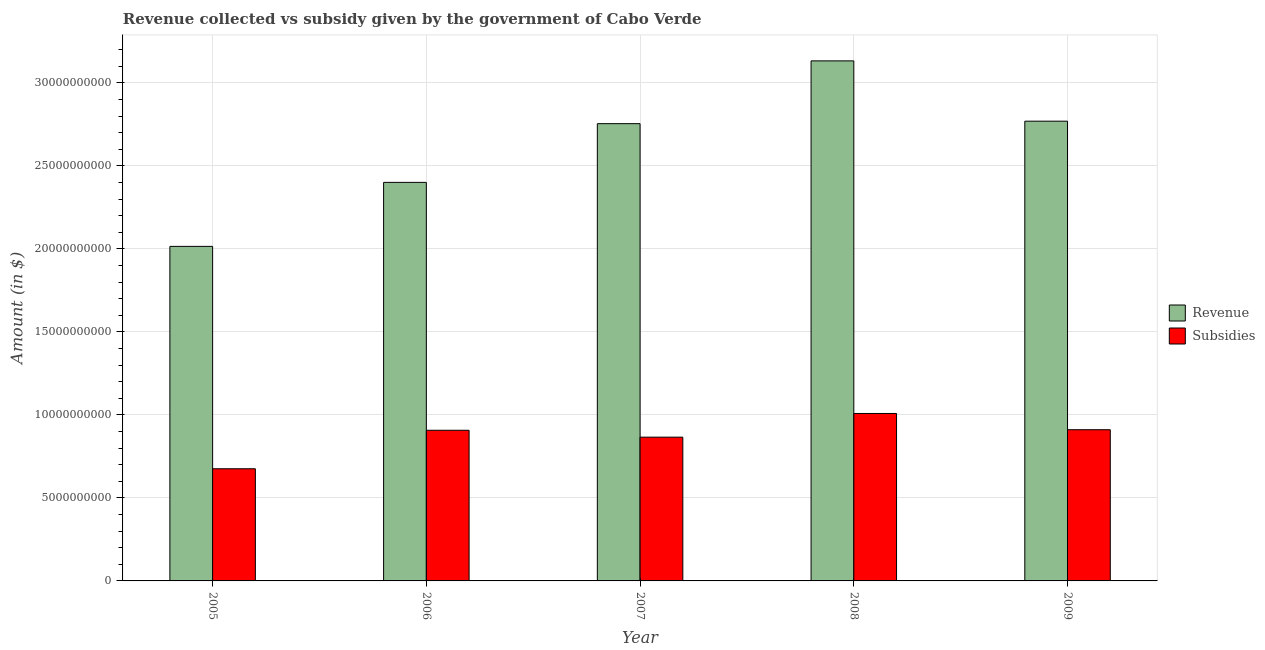How many groups of bars are there?
Keep it short and to the point. 5. Are the number of bars per tick equal to the number of legend labels?
Your answer should be compact. Yes. How many bars are there on the 1st tick from the right?
Your answer should be very brief. 2. In how many cases, is the number of bars for a given year not equal to the number of legend labels?
Give a very brief answer. 0. What is the amount of revenue collected in 2009?
Make the answer very short. 2.77e+1. Across all years, what is the maximum amount of revenue collected?
Provide a succinct answer. 3.13e+1. Across all years, what is the minimum amount of revenue collected?
Give a very brief answer. 2.02e+1. In which year was the amount of revenue collected maximum?
Offer a terse response. 2008. What is the total amount of revenue collected in the graph?
Provide a succinct answer. 1.31e+11. What is the difference between the amount of revenue collected in 2005 and that in 2008?
Offer a very short reply. -1.12e+1. What is the difference between the amount of subsidies given in 2009 and the amount of revenue collected in 2008?
Provide a short and direct response. -9.79e+08. What is the average amount of subsidies given per year?
Your answer should be very brief. 8.74e+09. In the year 2008, what is the difference between the amount of subsidies given and amount of revenue collected?
Keep it short and to the point. 0. In how many years, is the amount of revenue collected greater than 22000000000 $?
Your response must be concise. 4. What is the ratio of the amount of subsidies given in 2005 to that in 2007?
Ensure brevity in your answer.  0.78. What is the difference between the highest and the second highest amount of subsidies given?
Give a very brief answer. 9.79e+08. What is the difference between the highest and the lowest amount of subsidies given?
Your answer should be very brief. 3.33e+09. What does the 2nd bar from the left in 2005 represents?
Offer a very short reply. Subsidies. What does the 1st bar from the right in 2006 represents?
Offer a very short reply. Subsidies. Are all the bars in the graph horizontal?
Give a very brief answer. No. What is the difference between two consecutive major ticks on the Y-axis?
Provide a succinct answer. 5.00e+09. Does the graph contain any zero values?
Provide a short and direct response. No. Does the graph contain grids?
Keep it short and to the point. Yes. How many legend labels are there?
Give a very brief answer. 2. What is the title of the graph?
Offer a very short reply. Revenue collected vs subsidy given by the government of Cabo Verde. Does "Enforce a contract" appear as one of the legend labels in the graph?
Your answer should be very brief. No. What is the label or title of the X-axis?
Your answer should be compact. Year. What is the label or title of the Y-axis?
Provide a short and direct response. Amount (in $). What is the Amount (in $) of Revenue in 2005?
Offer a very short reply. 2.02e+1. What is the Amount (in $) of Subsidies in 2005?
Your answer should be very brief. 6.76e+09. What is the Amount (in $) of Revenue in 2006?
Provide a succinct answer. 2.40e+1. What is the Amount (in $) of Subsidies in 2006?
Make the answer very short. 9.07e+09. What is the Amount (in $) of Revenue in 2007?
Your answer should be compact. 2.75e+1. What is the Amount (in $) of Subsidies in 2007?
Your answer should be very brief. 8.66e+09. What is the Amount (in $) of Revenue in 2008?
Provide a short and direct response. 3.13e+1. What is the Amount (in $) of Subsidies in 2008?
Provide a succinct answer. 1.01e+1. What is the Amount (in $) in Revenue in 2009?
Your answer should be very brief. 2.77e+1. What is the Amount (in $) of Subsidies in 2009?
Provide a short and direct response. 9.11e+09. Across all years, what is the maximum Amount (in $) of Revenue?
Provide a short and direct response. 3.13e+1. Across all years, what is the maximum Amount (in $) of Subsidies?
Offer a very short reply. 1.01e+1. Across all years, what is the minimum Amount (in $) of Revenue?
Offer a very short reply. 2.02e+1. Across all years, what is the minimum Amount (in $) in Subsidies?
Your answer should be very brief. 6.76e+09. What is the total Amount (in $) in Revenue in the graph?
Ensure brevity in your answer.  1.31e+11. What is the total Amount (in $) of Subsidies in the graph?
Your response must be concise. 4.37e+1. What is the difference between the Amount (in $) of Revenue in 2005 and that in 2006?
Keep it short and to the point. -3.85e+09. What is the difference between the Amount (in $) in Subsidies in 2005 and that in 2006?
Keep it short and to the point. -2.32e+09. What is the difference between the Amount (in $) of Revenue in 2005 and that in 2007?
Ensure brevity in your answer.  -7.39e+09. What is the difference between the Amount (in $) of Subsidies in 2005 and that in 2007?
Your answer should be very brief. -1.90e+09. What is the difference between the Amount (in $) in Revenue in 2005 and that in 2008?
Provide a short and direct response. -1.12e+1. What is the difference between the Amount (in $) of Subsidies in 2005 and that in 2008?
Offer a very short reply. -3.33e+09. What is the difference between the Amount (in $) in Revenue in 2005 and that in 2009?
Ensure brevity in your answer.  -7.54e+09. What is the difference between the Amount (in $) of Subsidies in 2005 and that in 2009?
Provide a succinct answer. -2.35e+09. What is the difference between the Amount (in $) of Revenue in 2006 and that in 2007?
Provide a short and direct response. -3.54e+09. What is the difference between the Amount (in $) in Subsidies in 2006 and that in 2007?
Make the answer very short. 4.15e+08. What is the difference between the Amount (in $) in Revenue in 2006 and that in 2008?
Provide a succinct answer. -7.32e+09. What is the difference between the Amount (in $) in Subsidies in 2006 and that in 2008?
Make the answer very short. -1.01e+09. What is the difference between the Amount (in $) in Revenue in 2006 and that in 2009?
Your answer should be very brief. -3.69e+09. What is the difference between the Amount (in $) in Subsidies in 2006 and that in 2009?
Ensure brevity in your answer.  -3.27e+07. What is the difference between the Amount (in $) in Revenue in 2007 and that in 2008?
Provide a short and direct response. -3.78e+09. What is the difference between the Amount (in $) in Subsidies in 2007 and that in 2008?
Your answer should be very brief. -1.43e+09. What is the difference between the Amount (in $) in Revenue in 2007 and that in 2009?
Give a very brief answer. -1.49e+08. What is the difference between the Amount (in $) in Subsidies in 2007 and that in 2009?
Provide a succinct answer. -4.48e+08. What is the difference between the Amount (in $) in Revenue in 2008 and that in 2009?
Your answer should be very brief. 3.63e+09. What is the difference between the Amount (in $) of Subsidies in 2008 and that in 2009?
Your answer should be very brief. 9.79e+08. What is the difference between the Amount (in $) in Revenue in 2005 and the Amount (in $) in Subsidies in 2006?
Your answer should be very brief. 1.11e+1. What is the difference between the Amount (in $) of Revenue in 2005 and the Amount (in $) of Subsidies in 2007?
Make the answer very short. 1.15e+1. What is the difference between the Amount (in $) of Revenue in 2005 and the Amount (in $) of Subsidies in 2008?
Offer a very short reply. 1.01e+1. What is the difference between the Amount (in $) of Revenue in 2005 and the Amount (in $) of Subsidies in 2009?
Give a very brief answer. 1.10e+1. What is the difference between the Amount (in $) of Revenue in 2006 and the Amount (in $) of Subsidies in 2007?
Ensure brevity in your answer.  1.53e+1. What is the difference between the Amount (in $) of Revenue in 2006 and the Amount (in $) of Subsidies in 2008?
Ensure brevity in your answer.  1.39e+1. What is the difference between the Amount (in $) in Revenue in 2006 and the Amount (in $) in Subsidies in 2009?
Offer a very short reply. 1.49e+1. What is the difference between the Amount (in $) in Revenue in 2007 and the Amount (in $) in Subsidies in 2008?
Ensure brevity in your answer.  1.75e+1. What is the difference between the Amount (in $) in Revenue in 2007 and the Amount (in $) in Subsidies in 2009?
Your answer should be very brief. 1.84e+1. What is the difference between the Amount (in $) of Revenue in 2008 and the Amount (in $) of Subsidies in 2009?
Ensure brevity in your answer.  2.22e+1. What is the average Amount (in $) in Revenue per year?
Make the answer very short. 2.61e+1. What is the average Amount (in $) of Subsidies per year?
Your answer should be compact. 8.74e+09. In the year 2005, what is the difference between the Amount (in $) in Revenue and Amount (in $) in Subsidies?
Provide a succinct answer. 1.34e+1. In the year 2006, what is the difference between the Amount (in $) of Revenue and Amount (in $) of Subsidies?
Your answer should be compact. 1.49e+1. In the year 2007, what is the difference between the Amount (in $) in Revenue and Amount (in $) in Subsidies?
Make the answer very short. 1.89e+1. In the year 2008, what is the difference between the Amount (in $) in Revenue and Amount (in $) in Subsidies?
Give a very brief answer. 2.12e+1. In the year 2009, what is the difference between the Amount (in $) of Revenue and Amount (in $) of Subsidies?
Keep it short and to the point. 1.86e+1. What is the ratio of the Amount (in $) in Revenue in 2005 to that in 2006?
Ensure brevity in your answer.  0.84. What is the ratio of the Amount (in $) in Subsidies in 2005 to that in 2006?
Your response must be concise. 0.74. What is the ratio of the Amount (in $) in Revenue in 2005 to that in 2007?
Provide a succinct answer. 0.73. What is the ratio of the Amount (in $) of Subsidies in 2005 to that in 2007?
Your answer should be compact. 0.78. What is the ratio of the Amount (in $) in Revenue in 2005 to that in 2008?
Keep it short and to the point. 0.64. What is the ratio of the Amount (in $) of Subsidies in 2005 to that in 2008?
Offer a very short reply. 0.67. What is the ratio of the Amount (in $) in Revenue in 2005 to that in 2009?
Give a very brief answer. 0.73. What is the ratio of the Amount (in $) of Subsidies in 2005 to that in 2009?
Keep it short and to the point. 0.74. What is the ratio of the Amount (in $) of Revenue in 2006 to that in 2007?
Offer a terse response. 0.87. What is the ratio of the Amount (in $) of Subsidies in 2006 to that in 2007?
Give a very brief answer. 1.05. What is the ratio of the Amount (in $) of Revenue in 2006 to that in 2008?
Your answer should be very brief. 0.77. What is the ratio of the Amount (in $) in Subsidies in 2006 to that in 2008?
Offer a very short reply. 0.9. What is the ratio of the Amount (in $) in Revenue in 2006 to that in 2009?
Ensure brevity in your answer.  0.87. What is the ratio of the Amount (in $) of Subsidies in 2006 to that in 2009?
Keep it short and to the point. 1. What is the ratio of the Amount (in $) in Revenue in 2007 to that in 2008?
Your answer should be very brief. 0.88. What is the ratio of the Amount (in $) of Subsidies in 2007 to that in 2008?
Your answer should be compact. 0.86. What is the ratio of the Amount (in $) of Subsidies in 2007 to that in 2009?
Give a very brief answer. 0.95. What is the ratio of the Amount (in $) in Revenue in 2008 to that in 2009?
Provide a short and direct response. 1.13. What is the ratio of the Amount (in $) of Subsidies in 2008 to that in 2009?
Ensure brevity in your answer.  1.11. What is the difference between the highest and the second highest Amount (in $) of Revenue?
Make the answer very short. 3.63e+09. What is the difference between the highest and the second highest Amount (in $) in Subsidies?
Your response must be concise. 9.79e+08. What is the difference between the highest and the lowest Amount (in $) of Revenue?
Offer a terse response. 1.12e+1. What is the difference between the highest and the lowest Amount (in $) of Subsidies?
Offer a very short reply. 3.33e+09. 